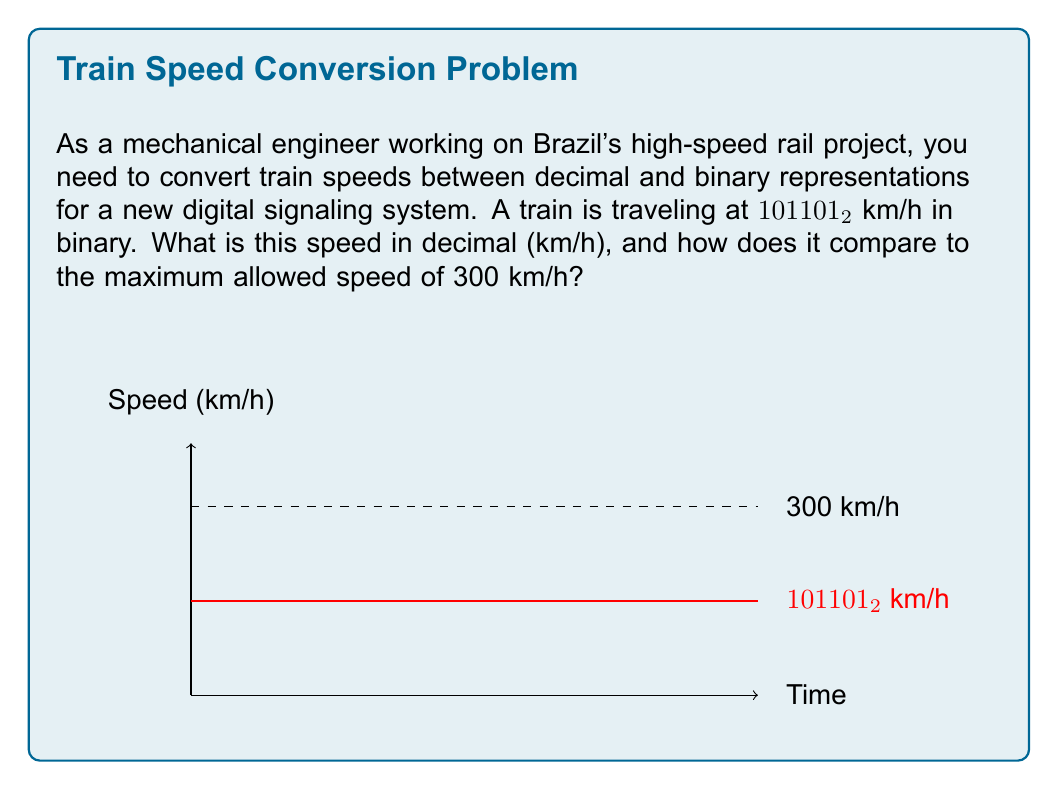Show me your answer to this math problem. To solve this problem, we need to convert the binary speed to decimal and then compare it to the maximum speed. Let's break it down step-by-step:

1. Convert 101101₂ from binary to decimal:
   $101101_2 = (1 \times 2^5) + (0 \times 2^4) + (1 \times 2^3) + (1 \times 2^2) + (0 \times 2^1) + (1 \times 2^0)$
   $= 32 + 0 + 8 + 4 + 0 + 1$
   $= 45_{10}$

2. The train's speed in decimal is 45 km/h.

3. Compare to the maximum speed:
   Maximum speed = 300 km/h
   Train's current speed = 45 km/h

4. Calculate the difference:
   $300 - 45 = 255$ km/h

5. Express the difference as a percentage:
   $\frac{45}{300} \times 100\% = 15\%$

Therefore, the train is traveling at 45 km/h, which is 255 km/h below the maximum speed and only 15% of the maximum allowed speed.
Answer: 45 km/h; 255 km/h below maximum; 15% of maximum speed 